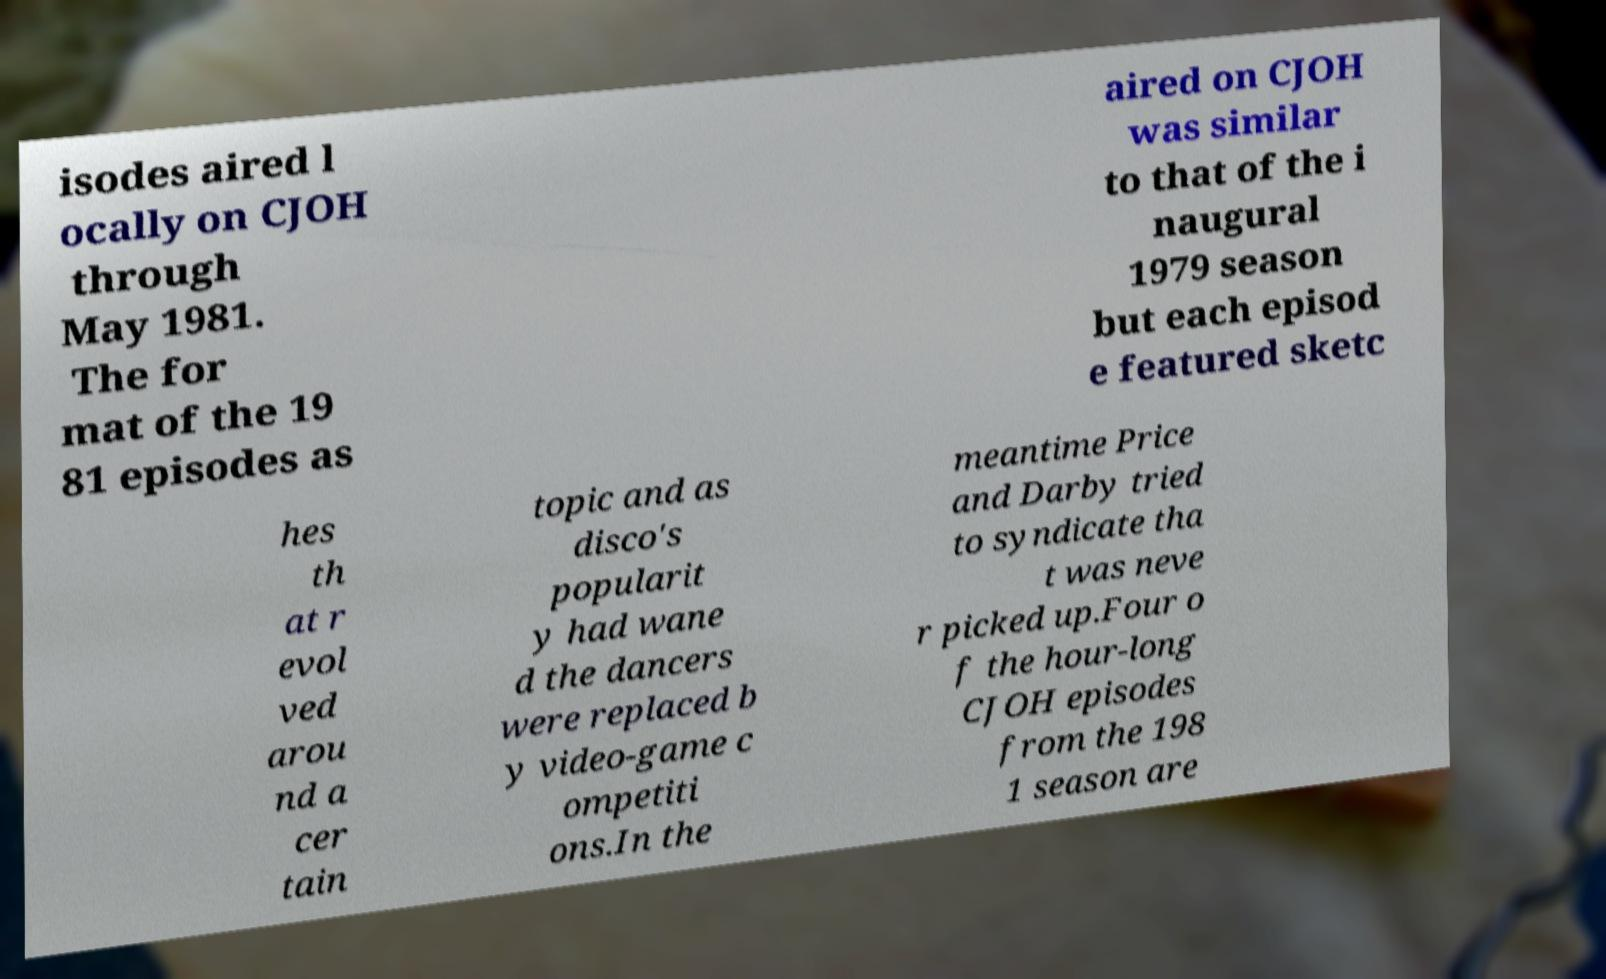Please identify and transcribe the text found in this image. isodes aired l ocally on CJOH through May 1981. The for mat of the 19 81 episodes as aired on CJOH was similar to that of the i naugural 1979 season but each episod e featured sketc hes th at r evol ved arou nd a cer tain topic and as disco's popularit y had wane d the dancers were replaced b y video-game c ompetiti ons.In the meantime Price and Darby tried to syndicate tha t was neve r picked up.Four o f the hour-long CJOH episodes from the 198 1 season are 